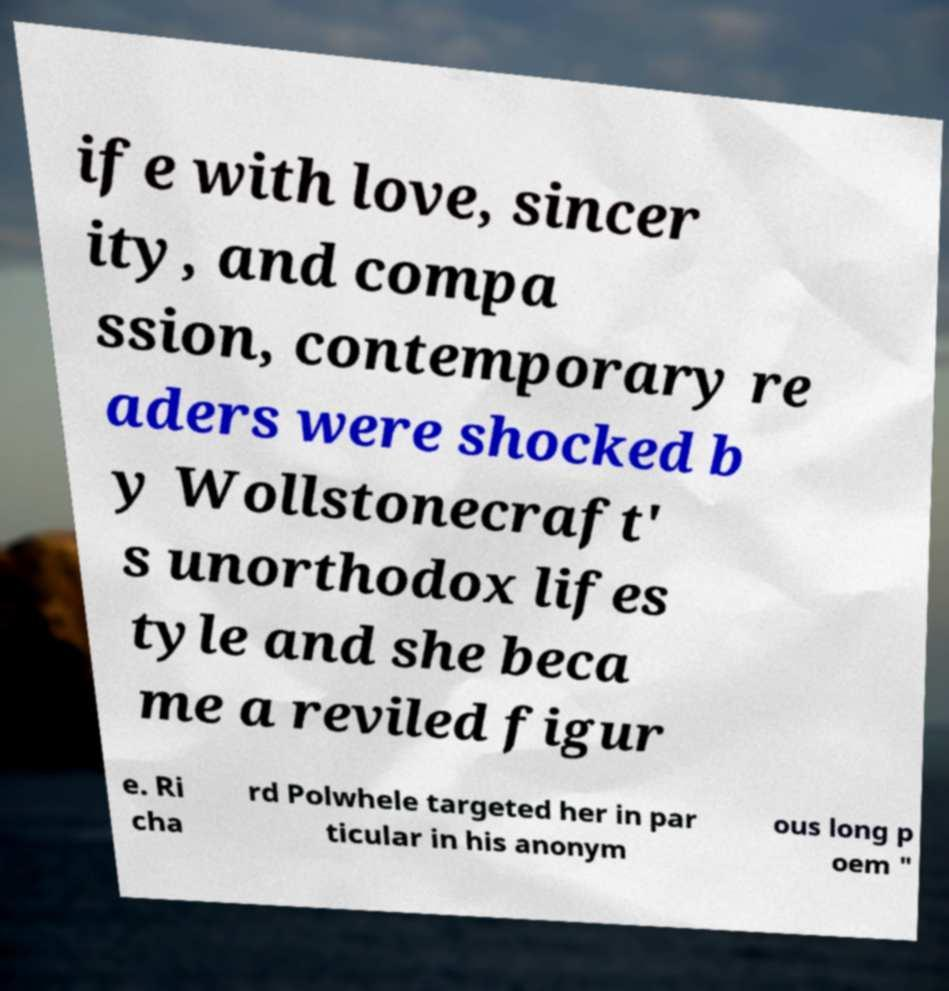For documentation purposes, I need the text within this image transcribed. Could you provide that? ife with love, sincer ity, and compa ssion, contemporary re aders were shocked b y Wollstonecraft' s unorthodox lifes tyle and she beca me a reviled figur e. Ri cha rd Polwhele targeted her in par ticular in his anonym ous long p oem " 